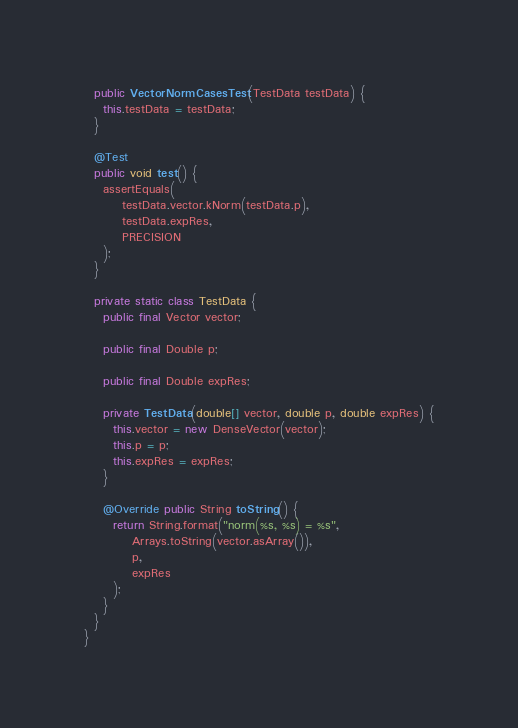<code> <loc_0><loc_0><loc_500><loc_500><_Java_>  public VectorNormCasesTest(TestData testData) {
    this.testData = testData;
  }

  @Test
  public void test() {
    assertEquals(
        testData.vector.kNorm(testData.p),
        testData.expRes,
        PRECISION
    );
  }

  private static class TestData {
    public final Vector vector;

    public final Double p;

    public final Double expRes;

    private TestData(double[] vector, double p, double expRes) {
      this.vector = new DenseVector(vector);
      this.p = p;
      this.expRes = expRes;
    }

    @Override public String toString() {
      return String.format("norm(%s, %s) = %s",
          Arrays.toString(vector.asArray()),
          p,
          expRes
      );
    }
  }
}
</code> 